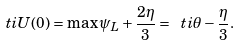Convert formula to latex. <formula><loc_0><loc_0><loc_500><loc_500>\ t i { U } ( 0 ) = \max \psi _ { L } + \frac { 2 \eta } { 3 } = \ t i { \theta } - \frac { \eta } { 3 } .</formula> 